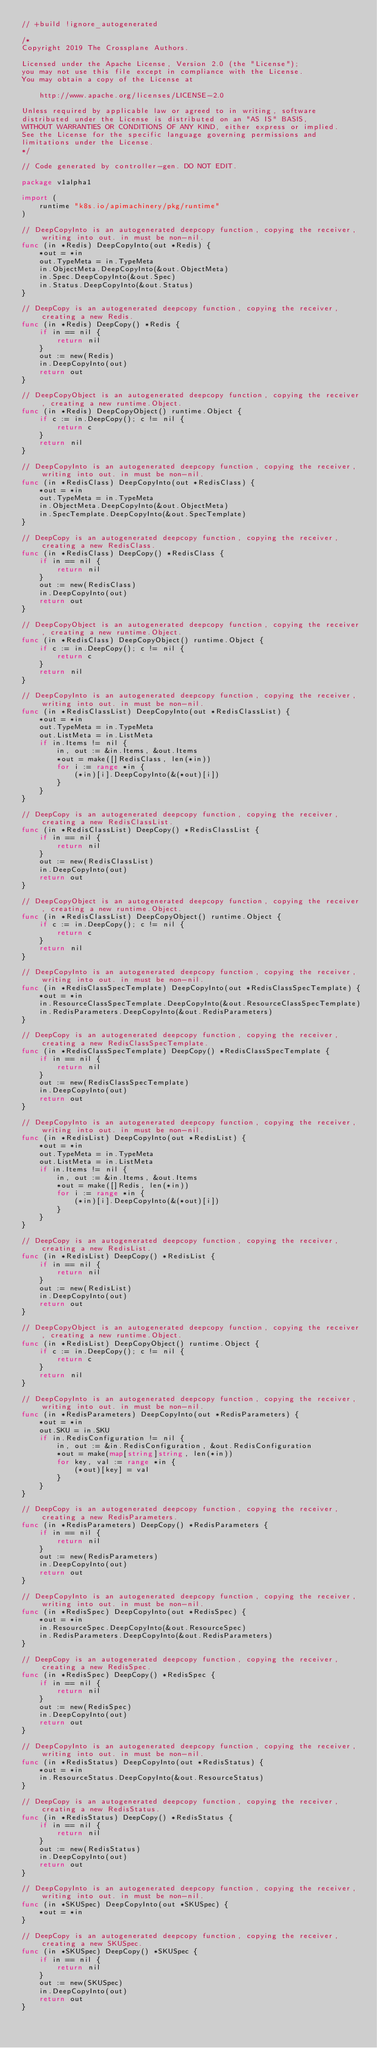<code> <loc_0><loc_0><loc_500><loc_500><_Go_>// +build !ignore_autogenerated

/*
Copyright 2019 The Crossplane Authors.

Licensed under the Apache License, Version 2.0 (the "License");
you may not use this file except in compliance with the License.
You may obtain a copy of the License at

    http://www.apache.org/licenses/LICENSE-2.0

Unless required by applicable law or agreed to in writing, software
distributed under the License is distributed on an "AS IS" BASIS,
WITHOUT WARRANTIES OR CONDITIONS OF ANY KIND, either express or implied.
See the License for the specific language governing permissions and
limitations under the License.
*/

// Code generated by controller-gen. DO NOT EDIT.

package v1alpha1

import (
	runtime "k8s.io/apimachinery/pkg/runtime"
)

// DeepCopyInto is an autogenerated deepcopy function, copying the receiver, writing into out. in must be non-nil.
func (in *Redis) DeepCopyInto(out *Redis) {
	*out = *in
	out.TypeMeta = in.TypeMeta
	in.ObjectMeta.DeepCopyInto(&out.ObjectMeta)
	in.Spec.DeepCopyInto(&out.Spec)
	in.Status.DeepCopyInto(&out.Status)
}

// DeepCopy is an autogenerated deepcopy function, copying the receiver, creating a new Redis.
func (in *Redis) DeepCopy() *Redis {
	if in == nil {
		return nil
	}
	out := new(Redis)
	in.DeepCopyInto(out)
	return out
}

// DeepCopyObject is an autogenerated deepcopy function, copying the receiver, creating a new runtime.Object.
func (in *Redis) DeepCopyObject() runtime.Object {
	if c := in.DeepCopy(); c != nil {
		return c
	}
	return nil
}

// DeepCopyInto is an autogenerated deepcopy function, copying the receiver, writing into out. in must be non-nil.
func (in *RedisClass) DeepCopyInto(out *RedisClass) {
	*out = *in
	out.TypeMeta = in.TypeMeta
	in.ObjectMeta.DeepCopyInto(&out.ObjectMeta)
	in.SpecTemplate.DeepCopyInto(&out.SpecTemplate)
}

// DeepCopy is an autogenerated deepcopy function, copying the receiver, creating a new RedisClass.
func (in *RedisClass) DeepCopy() *RedisClass {
	if in == nil {
		return nil
	}
	out := new(RedisClass)
	in.DeepCopyInto(out)
	return out
}

// DeepCopyObject is an autogenerated deepcopy function, copying the receiver, creating a new runtime.Object.
func (in *RedisClass) DeepCopyObject() runtime.Object {
	if c := in.DeepCopy(); c != nil {
		return c
	}
	return nil
}

// DeepCopyInto is an autogenerated deepcopy function, copying the receiver, writing into out. in must be non-nil.
func (in *RedisClassList) DeepCopyInto(out *RedisClassList) {
	*out = *in
	out.TypeMeta = in.TypeMeta
	out.ListMeta = in.ListMeta
	if in.Items != nil {
		in, out := &in.Items, &out.Items
		*out = make([]RedisClass, len(*in))
		for i := range *in {
			(*in)[i].DeepCopyInto(&(*out)[i])
		}
	}
}

// DeepCopy is an autogenerated deepcopy function, copying the receiver, creating a new RedisClassList.
func (in *RedisClassList) DeepCopy() *RedisClassList {
	if in == nil {
		return nil
	}
	out := new(RedisClassList)
	in.DeepCopyInto(out)
	return out
}

// DeepCopyObject is an autogenerated deepcopy function, copying the receiver, creating a new runtime.Object.
func (in *RedisClassList) DeepCopyObject() runtime.Object {
	if c := in.DeepCopy(); c != nil {
		return c
	}
	return nil
}

// DeepCopyInto is an autogenerated deepcopy function, copying the receiver, writing into out. in must be non-nil.
func (in *RedisClassSpecTemplate) DeepCopyInto(out *RedisClassSpecTemplate) {
	*out = *in
	in.ResourceClassSpecTemplate.DeepCopyInto(&out.ResourceClassSpecTemplate)
	in.RedisParameters.DeepCopyInto(&out.RedisParameters)
}

// DeepCopy is an autogenerated deepcopy function, copying the receiver, creating a new RedisClassSpecTemplate.
func (in *RedisClassSpecTemplate) DeepCopy() *RedisClassSpecTemplate {
	if in == nil {
		return nil
	}
	out := new(RedisClassSpecTemplate)
	in.DeepCopyInto(out)
	return out
}

// DeepCopyInto is an autogenerated deepcopy function, copying the receiver, writing into out. in must be non-nil.
func (in *RedisList) DeepCopyInto(out *RedisList) {
	*out = *in
	out.TypeMeta = in.TypeMeta
	out.ListMeta = in.ListMeta
	if in.Items != nil {
		in, out := &in.Items, &out.Items
		*out = make([]Redis, len(*in))
		for i := range *in {
			(*in)[i].DeepCopyInto(&(*out)[i])
		}
	}
}

// DeepCopy is an autogenerated deepcopy function, copying the receiver, creating a new RedisList.
func (in *RedisList) DeepCopy() *RedisList {
	if in == nil {
		return nil
	}
	out := new(RedisList)
	in.DeepCopyInto(out)
	return out
}

// DeepCopyObject is an autogenerated deepcopy function, copying the receiver, creating a new runtime.Object.
func (in *RedisList) DeepCopyObject() runtime.Object {
	if c := in.DeepCopy(); c != nil {
		return c
	}
	return nil
}

// DeepCopyInto is an autogenerated deepcopy function, copying the receiver, writing into out. in must be non-nil.
func (in *RedisParameters) DeepCopyInto(out *RedisParameters) {
	*out = *in
	out.SKU = in.SKU
	if in.RedisConfiguration != nil {
		in, out := &in.RedisConfiguration, &out.RedisConfiguration
		*out = make(map[string]string, len(*in))
		for key, val := range *in {
			(*out)[key] = val
		}
	}
}

// DeepCopy is an autogenerated deepcopy function, copying the receiver, creating a new RedisParameters.
func (in *RedisParameters) DeepCopy() *RedisParameters {
	if in == nil {
		return nil
	}
	out := new(RedisParameters)
	in.DeepCopyInto(out)
	return out
}

// DeepCopyInto is an autogenerated deepcopy function, copying the receiver, writing into out. in must be non-nil.
func (in *RedisSpec) DeepCopyInto(out *RedisSpec) {
	*out = *in
	in.ResourceSpec.DeepCopyInto(&out.ResourceSpec)
	in.RedisParameters.DeepCopyInto(&out.RedisParameters)
}

// DeepCopy is an autogenerated deepcopy function, copying the receiver, creating a new RedisSpec.
func (in *RedisSpec) DeepCopy() *RedisSpec {
	if in == nil {
		return nil
	}
	out := new(RedisSpec)
	in.DeepCopyInto(out)
	return out
}

// DeepCopyInto is an autogenerated deepcopy function, copying the receiver, writing into out. in must be non-nil.
func (in *RedisStatus) DeepCopyInto(out *RedisStatus) {
	*out = *in
	in.ResourceStatus.DeepCopyInto(&out.ResourceStatus)
}

// DeepCopy is an autogenerated deepcopy function, copying the receiver, creating a new RedisStatus.
func (in *RedisStatus) DeepCopy() *RedisStatus {
	if in == nil {
		return nil
	}
	out := new(RedisStatus)
	in.DeepCopyInto(out)
	return out
}

// DeepCopyInto is an autogenerated deepcopy function, copying the receiver, writing into out. in must be non-nil.
func (in *SKUSpec) DeepCopyInto(out *SKUSpec) {
	*out = *in
}

// DeepCopy is an autogenerated deepcopy function, copying the receiver, creating a new SKUSpec.
func (in *SKUSpec) DeepCopy() *SKUSpec {
	if in == nil {
		return nil
	}
	out := new(SKUSpec)
	in.DeepCopyInto(out)
	return out
}
</code> 